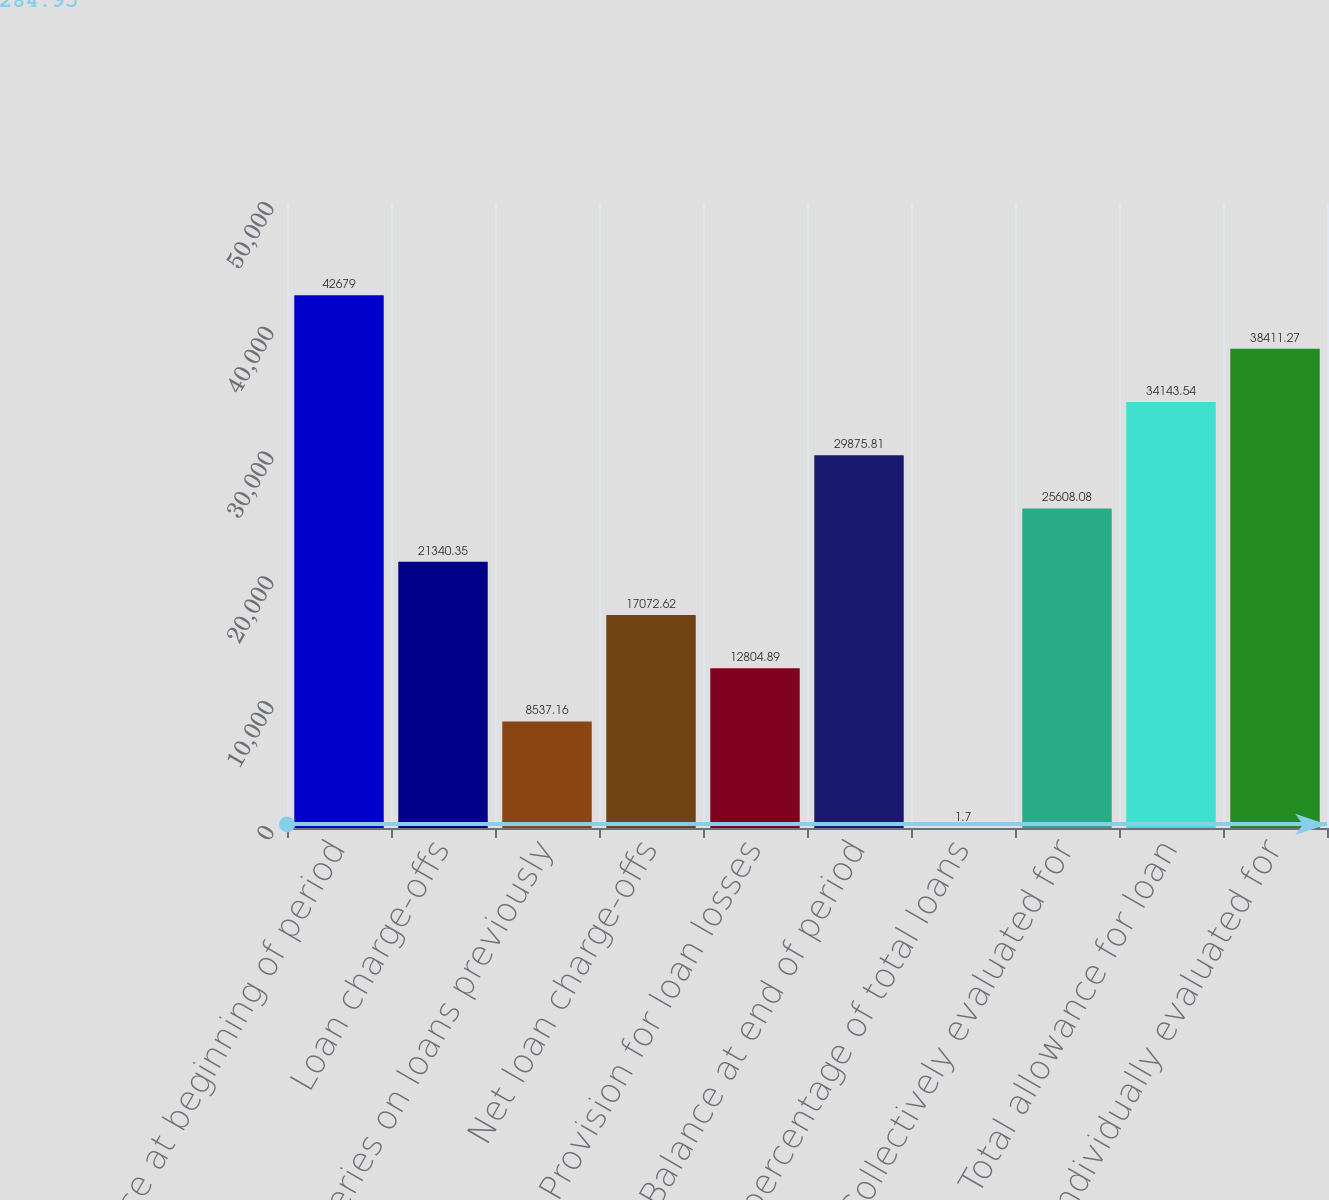Convert chart. <chart><loc_0><loc_0><loc_500><loc_500><bar_chart><fcel>Balance at beginning of period<fcel>Loan charge-offs<fcel>Recoveries on loans previously<fcel>Net loan charge-offs<fcel>Provision for loan losses<fcel>Balance at end of period<fcel>As a percentage of total loans<fcel>Collectively evaluated for<fcel>Total allowance for loan<fcel>Individually evaluated for<nl><fcel>42679<fcel>21340.3<fcel>8537.16<fcel>17072.6<fcel>12804.9<fcel>29875.8<fcel>1.7<fcel>25608.1<fcel>34143.5<fcel>38411.3<nl></chart> 